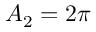<formula> <loc_0><loc_0><loc_500><loc_500>A _ { 2 } = 2 \pi</formula> 